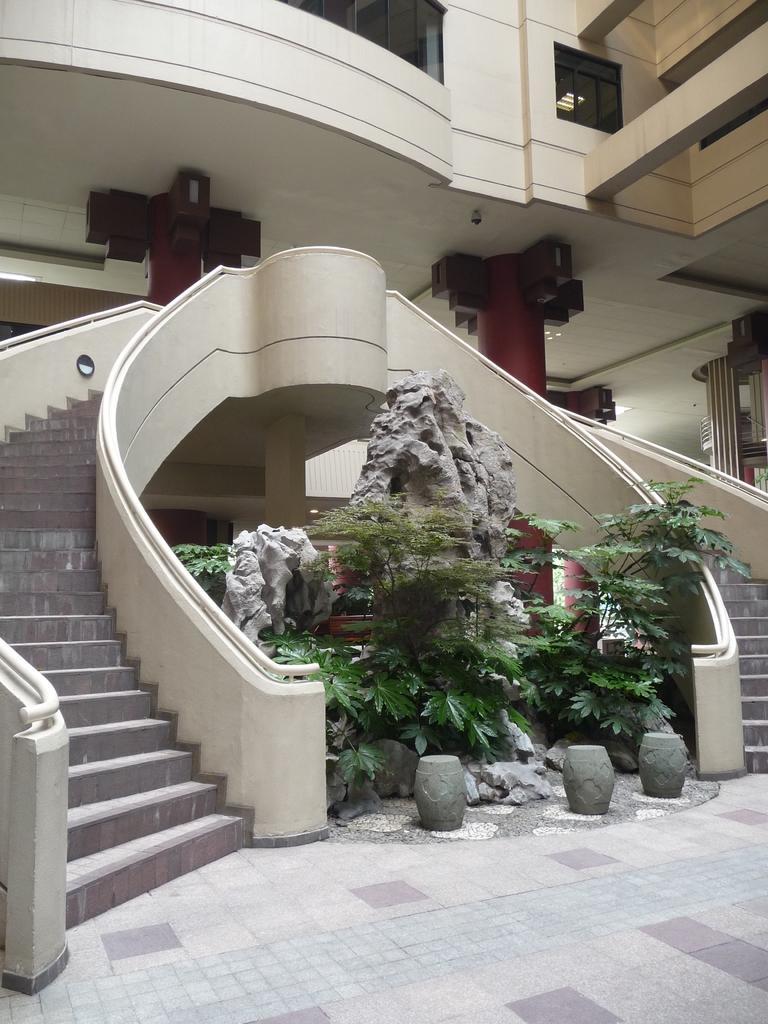Please provide a concise description of this image. In this image I can see the building which is in cream color. I can see the rock and plants in the front. There are stairs to the side of the plant. 